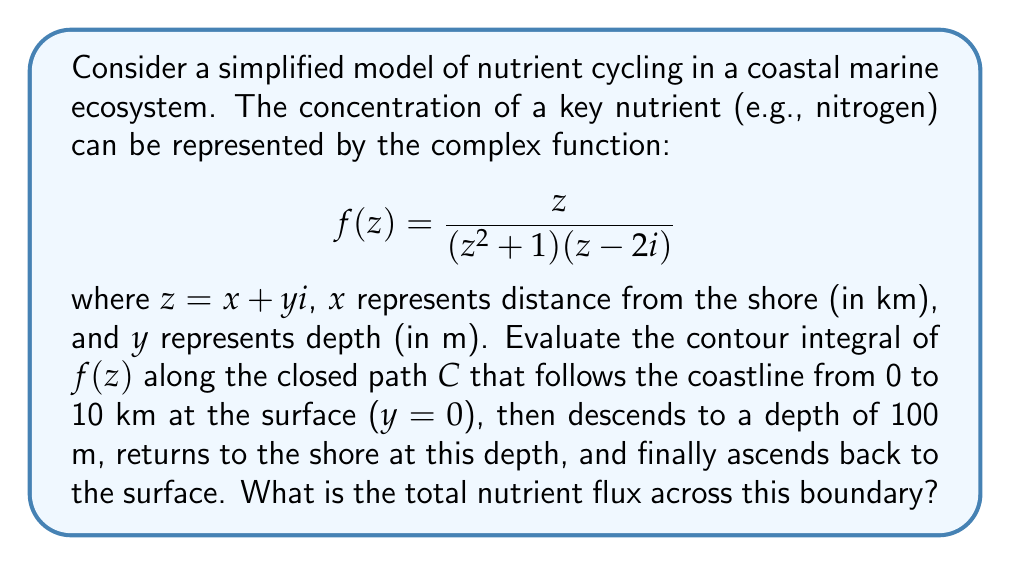Show me your answer to this math problem. To solve this problem, we'll use the Residue Theorem from complex analysis. The steps are as follows:

1) First, we need to identify the poles of $f(z)$ inside the contour $C$. The poles are at:
   $$z = i, z = -i, \text{ and } z = 2i$$
   Only $z = i$ and $z = 2i$ lie inside our contour.

2) We calculate the residues at these poles:

   At $z = i$:
   $$\text{Res}(f, i) = \lim_{z \to i} (z-i)f(z) = \lim_{z \to i} \frac{z(z-i)}{(z^2+1)(z-2i)} = \frac{i}{2(i-2i)} = \frac{1}{2}$$

   At $z = 2i$:
   $$\text{Res}(f, 2i) = \lim_{z \to 2i} (z-2i)f(z) = \lim_{z \to 2i} \frac{z}{(z^2+1)} = \frac{2i}{4i^2+1} = \frac{2i}{-3} = -\frac{2i}{3}$$

3) By the Residue Theorem:
   $$\oint_C f(z) dz = 2\pi i \sum \text{Res}(f, a_k)$$
   where $a_k$ are the poles inside $C$.

4) Substituting our residues:
   $$\oint_C f(z) dz = 2\pi i \left(\frac{1}{2} - \frac{2i}{3}\right) = \pi i - \frac{4\pi}{3}$$

5) The nutrient flux is represented by the real part of this integral:
   $$\text{Flux} = \text{Re}\left(\pi i - \frac{4\pi}{3}\right) = -\frac{4\pi}{3}$$
Answer: The total nutrient flux across the boundary is $-\frac{4\pi}{3}$ units. 